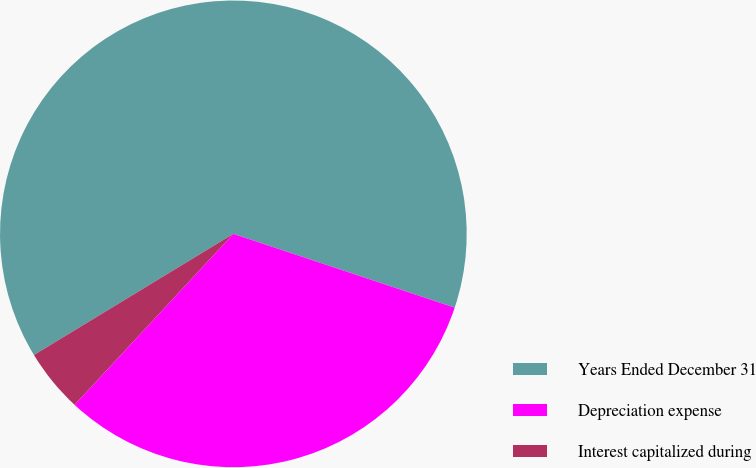<chart> <loc_0><loc_0><loc_500><loc_500><pie_chart><fcel>Years Ended December 31<fcel>Depreciation expense<fcel>Interest capitalized during<nl><fcel>63.81%<fcel>31.79%<fcel>4.4%<nl></chart> 